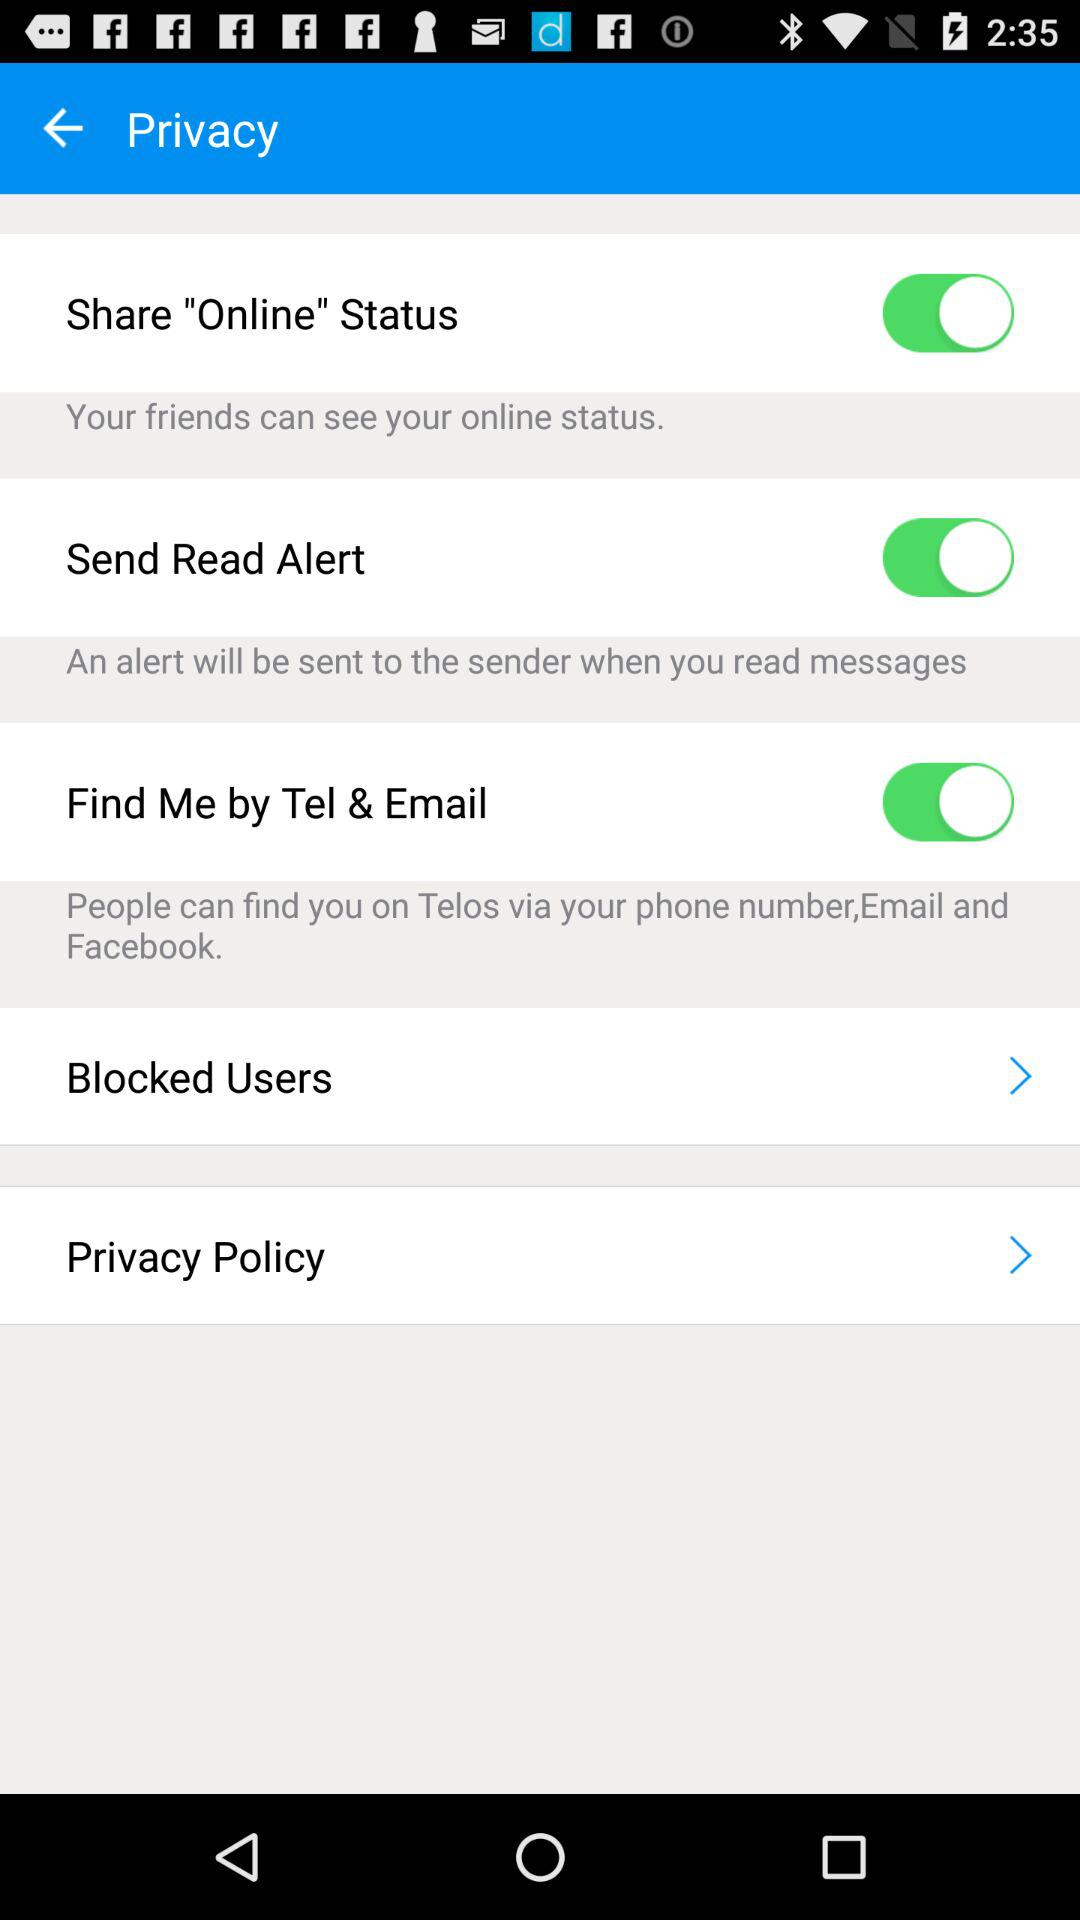What is the purpose of the 'Find Me by Tel & Email' option displayed in the image? The 'Find Me by Tel & Email' option in the image allows users to control whether they are searchable on the Telos platform by their phone number, email, or Facebook details. When enabled, it provides a way for other users to find someone's profile using these pieces of information. 